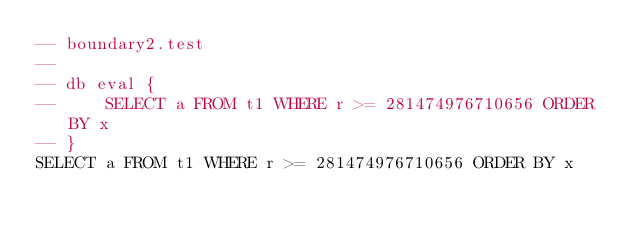<code> <loc_0><loc_0><loc_500><loc_500><_SQL_>-- boundary2.test
-- 
-- db eval {
--     SELECT a FROM t1 WHERE r >= 281474976710656 ORDER BY x
-- }
SELECT a FROM t1 WHERE r >= 281474976710656 ORDER BY x</code> 